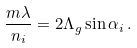<formula> <loc_0><loc_0><loc_500><loc_500>\frac { m \lambda } { n _ { i } } = 2 \Lambda _ { g } \sin \alpha _ { i } \, .</formula> 